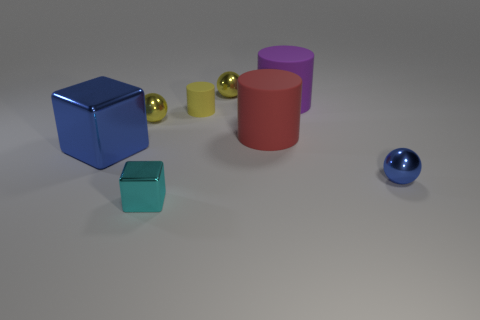There is a cyan metal thing; what number of small cyan metallic blocks are right of it?
Make the answer very short. 0. Is the number of brown spheres less than the number of blue shiny spheres?
Your response must be concise. Yes. There is a object that is both to the right of the large red rubber cylinder and in front of the red cylinder; what size is it?
Provide a short and direct response. Small. There is a ball that is in front of the large blue block; is its color the same as the small block?
Give a very brief answer. No. Are there fewer big blue things on the left side of the large metallic thing than tiny cyan metallic things?
Give a very brief answer. Yes. The large purple object that is the same material as the red thing is what shape?
Offer a very short reply. Cylinder. Are the small yellow cylinder and the blue block made of the same material?
Make the answer very short. No. Is the number of blue metallic balls that are to the right of the large purple object less than the number of yellow balls behind the yellow cylinder?
Offer a very short reply. No. The shiny ball that is the same color as the big metallic thing is what size?
Offer a terse response. Small. How many tiny things are on the right side of the tiny yellow metal thing that is left of the cube in front of the blue metal ball?
Provide a short and direct response. 4. 